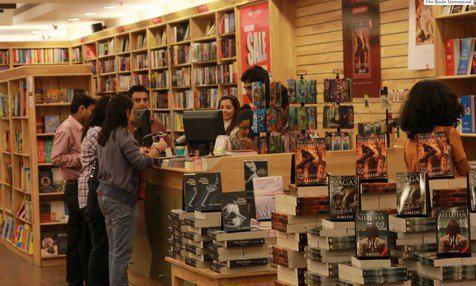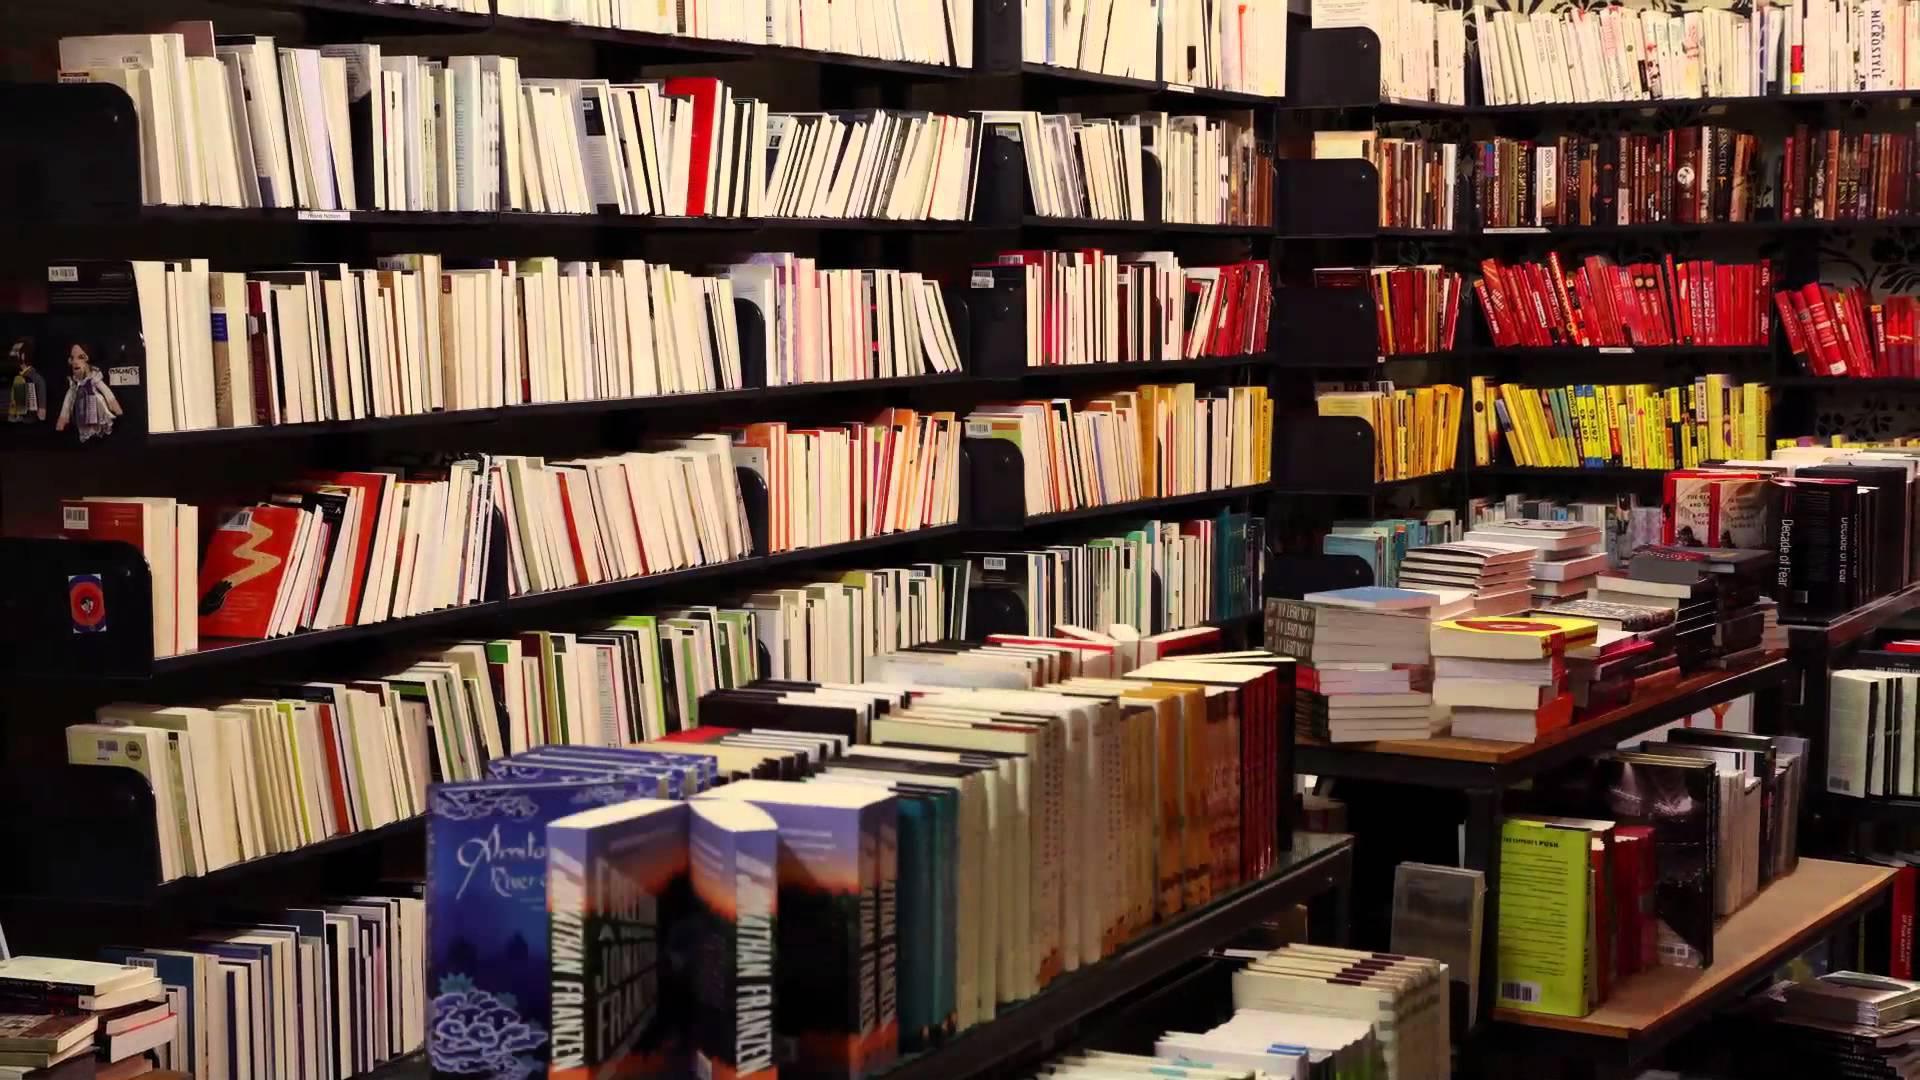The first image is the image on the left, the second image is the image on the right. Evaluate the accuracy of this statement regarding the images: "There are at least 4 people". Is it true? Answer yes or no. Yes. 